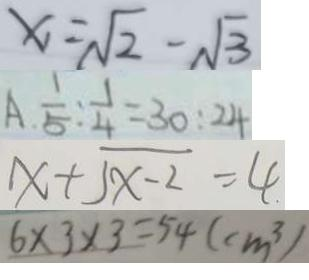<formula> <loc_0><loc_0><loc_500><loc_500>x _ { 1 } = \sqrt { 2 } - \sqrt { 3 } 
 A . \frac { 1 } { 5 } : \frac { 1 } { 4 } = 3 0 : 2 4 
 x + \sqrt { x - 2 } = 4 
 6 \times 3 \times 3 = 5 4 ( c m ^ { 3 } )</formula> 